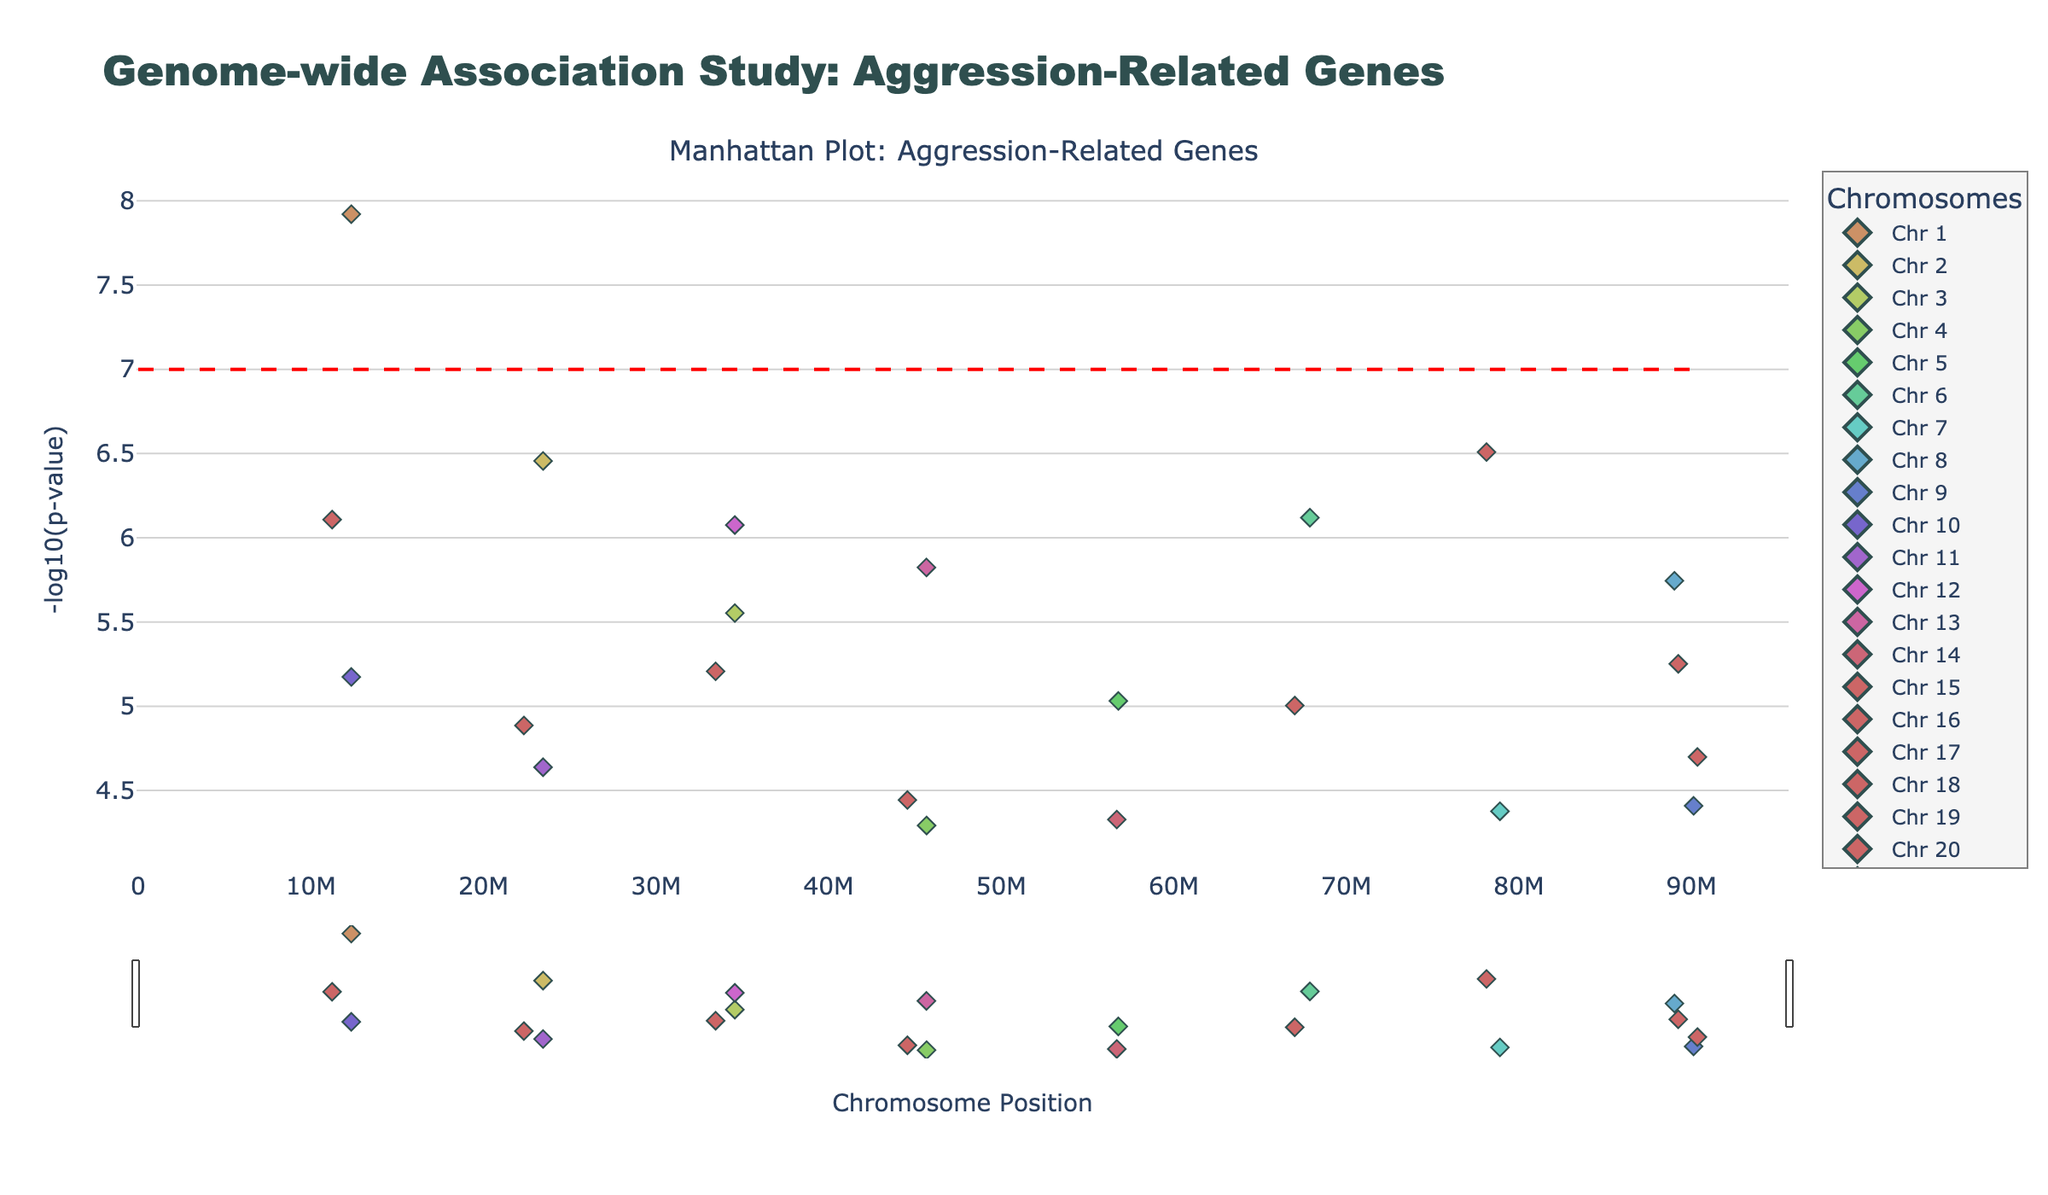What is the title of the plot? The title of the plot is usually found at the top of the figure, clearly indicating the purpose of the plot. In this case, it reads "Genome-wide Association Study: Aggression-Related Genes."
Answer: Genome-wide Association Study: Aggression-Related Genes Which chromosome has the highest significance in the plot? To find the chromosome with the highest significance, look for the point with the highest -log10(p-value). From the plot, the highest peak is on Chromosome 1.
Answer: Chromosome 1 What is the significance threshold indicated in the plot? The significance threshold is usually marked by a horizontal line. Here, it is indicated by a dashed red line at y=7.
Answer: 7 How many chromosomes show data points with a -log10(p-value) greater than 6? To answer this, count the number of chromosomes with markers above the y=6 line on the y-axis. Chromosomes 1, 2, 6, 8, 12, 13, and 19 have data points exceeding this value.
Answer: 7 Which gene has the second-highest -log10(p-value) in the plot? Identify the peaks based on their -log10(p-value). The second highest point is around y=6.5 on Chromosome 6, corresponding to the gene OXTR.
Answer: OXTR Compare the significance levels of the genes MAOA and MAOB. Which one is more significant? Look for the points representing MAOA and MAOB on Chromosomes 1 and 19, respectively. The point for MAOA is higher on the y-axis than MAOB.
Answer: MAOA What is the -log10(p-value) of the gene GABRA2? Find the gene GABRA2 on the plot, which is on Chromosome 12, and read the corresponding y-axis value.
Answer: Approximately 6.08 Are there any genes on Chromosome 7 with high significance? Observe the plot for Chromosome 7 and check if there are any peaks that stand out significantly. There are no high peaks on Chromosome 7 in this plot.
Answer: No What is the y-axis labeled in the plot? The label of the y-axis often indicates what the y-values represent. In this plot, it is labeled as '-log10(p-value).'
Answer: -log10(p-value) How does the significance of genes vary between Chromosome 3 and Chromosome 10? Compare the height of the points (y-axis values) on Chromosomes 3 and 10. Chromosome 3 has a lower significant peak compared to Chromosome 10.
Answer: Chromosome 10 is more significant 